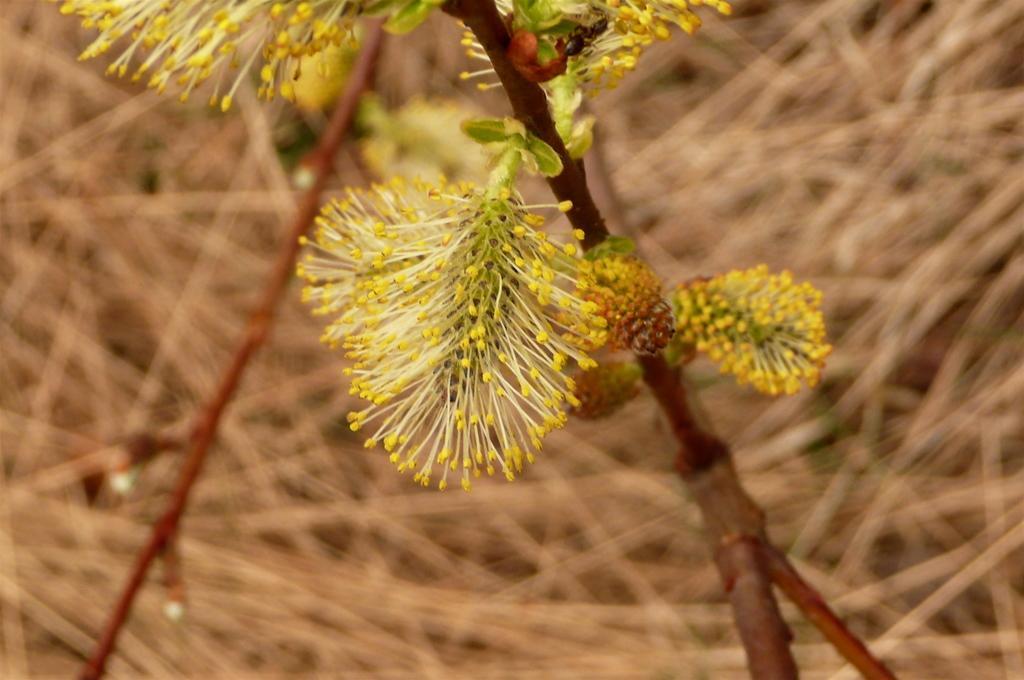Please provide a concise description of this image. In this image there is a plant with yellow color flowers, and there is blur background. 